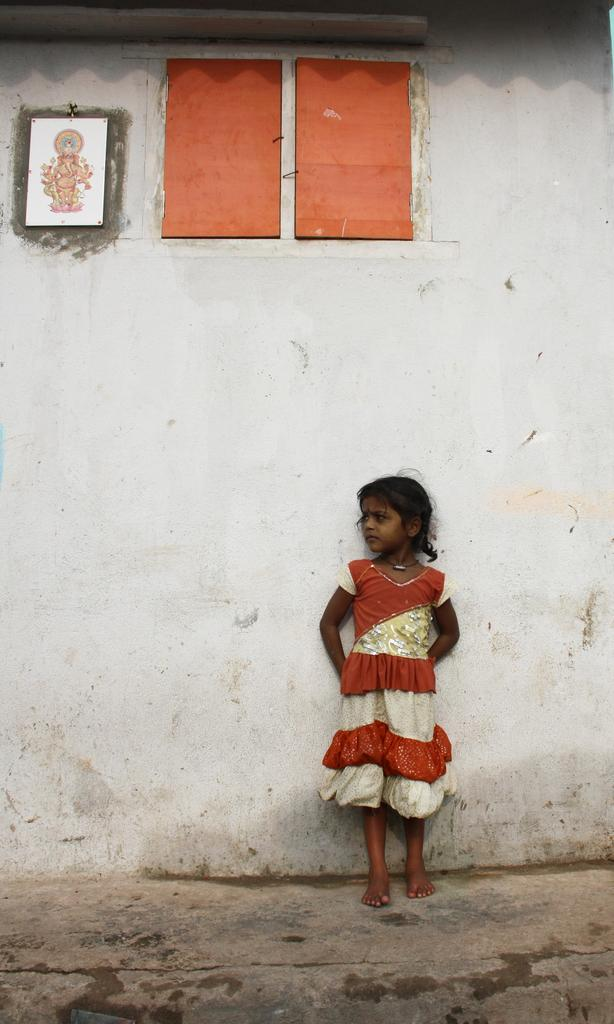What is the main subject of the image? There is a girl standing in the image. What is the girl doing in the image? The girl is leaning against a wall. What can be seen on the wall in the image? There is a picture on the wall and red color objects attached to it. What type of pest can be seen crawling on the girl in the image? There is no pest visible in the image; the girl is leaning against a wall with no pests present. What type of produce is being sold in the image? There is no produce being sold in the image; it features a girl leaning against a wall with a picture and red color objects on it. 